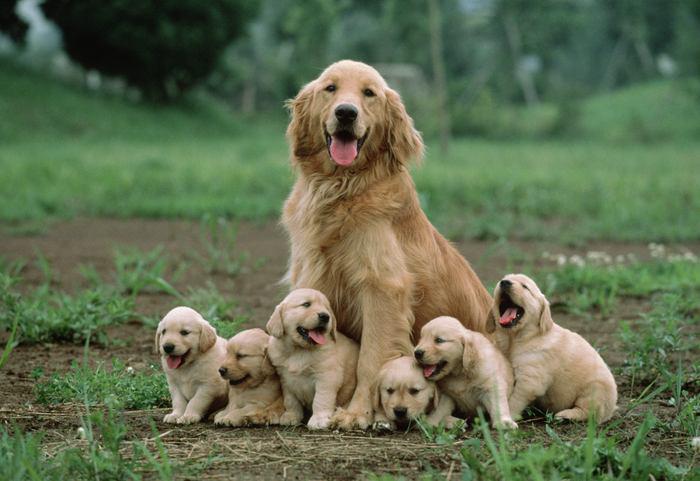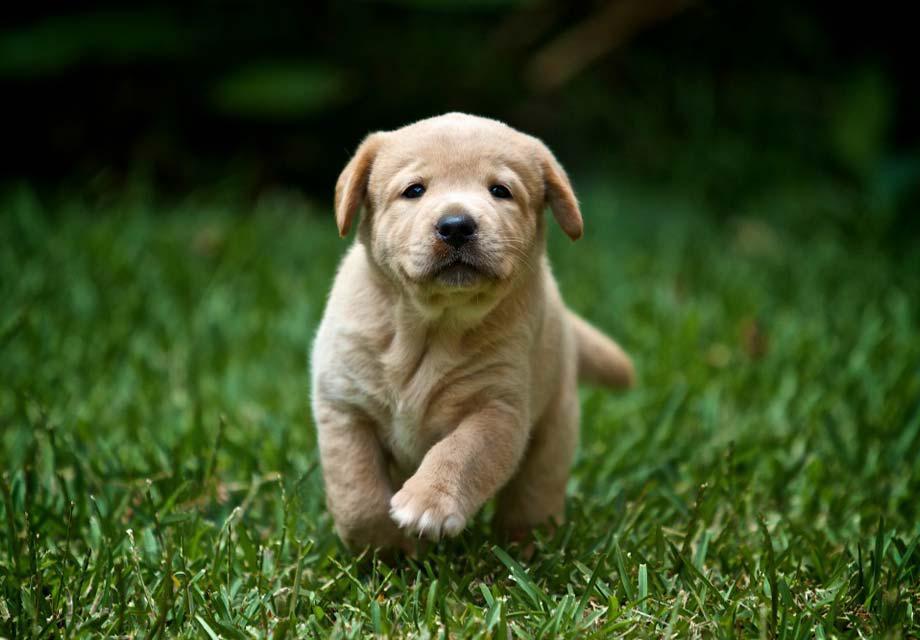The first image is the image on the left, the second image is the image on the right. For the images shown, is this caption "In 1 of the images, 1 dog is seated on an artificial surface." true? Answer yes or no. No. 